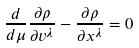<formula> <loc_0><loc_0><loc_500><loc_500>\frac { d } { d \mu } \frac { \partial \rho } { \partial v ^ { \lambda } } - \frac { \partial \rho } { \partial x ^ { \lambda } } = 0</formula> 